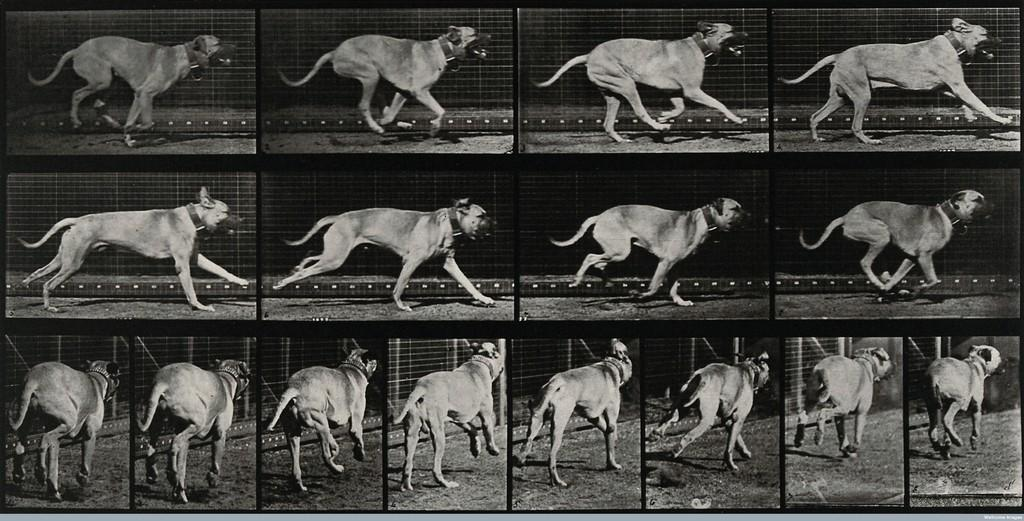What is the color scheme of the picture? The picture is black and white. What type of image is the picture? The picture is a collage of different images. What is the common subject in all the images in the collage? All the images in the collage contain a dog. What is unique about the dogs in each image? There is a belt around the neck of the dog in each image. What is visible behind the dog in each image? There is a fence behind the dog in each image. What type of butter can be seen melting on the eggs in the image? There is no butter or eggs present in the image; it is a collage of different images, all containing a dog with a belt around its neck and a fence in the background. 